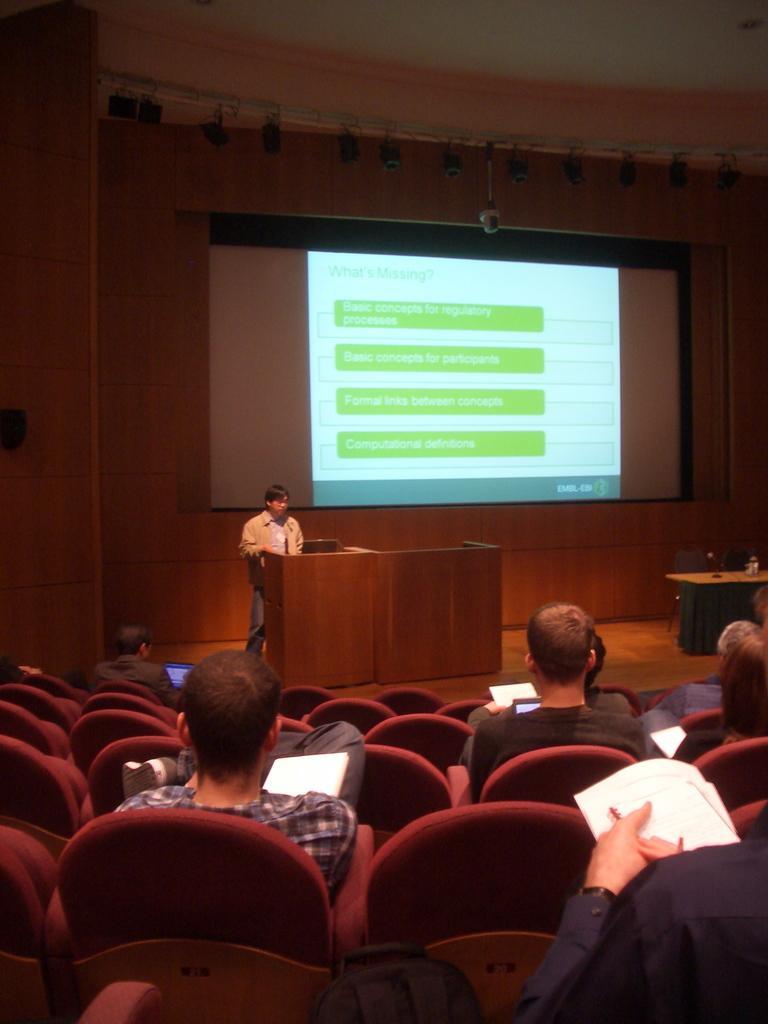In one or two sentences, can you explain what this image depicts? In a room there are many people sitting on the chair and holding papers in their hand. On the stage there is a man with brown jacket standing in front of the podium. To the right side of the stage there is a table. In the background there is a screen. 